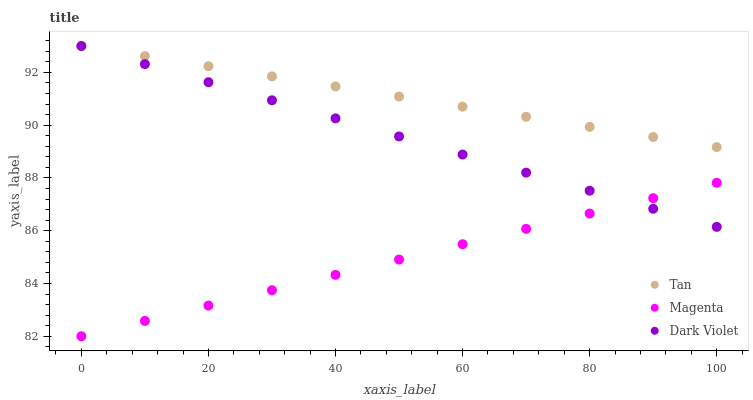Does Magenta have the minimum area under the curve?
Answer yes or no. Yes. Does Tan have the maximum area under the curve?
Answer yes or no. Yes. Does Dark Violet have the minimum area under the curve?
Answer yes or no. No. Does Dark Violet have the maximum area under the curve?
Answer yes or no. No. Is Tan the smoothest?
Answer yes or no. Yes. Is Magenta the roughest?
Answer yes or no. Yes. Is Dark Violet the smoothest?
Answer yes or no. No. Is Dark Violet the roughest?
Answer yes or no. No. Does Magenta have the lowest value?
Answer yes or no. Yes. Does Dark Violet have the lowest value?
Answer yes or no. No. Does Dark Violet have the highest value?
Answer yes or no. Yes. Does Magenta have the highest value?
Answer yes or no. No. Is Magenta less than Tan?
Answer yes or no. Yes. Is Tan greater than Magenta?
Answer yes or no. Yes. Does Dark Violet intersect Magenta?
Answer yes or no. Yes. Is Dark Violet less than Magenta?
Answer yes or no. No. Is Dark Violet greater than Magenta?
Answer yes or no. No. Does Magenta intersect Tan?
Answer yes or no. No. 